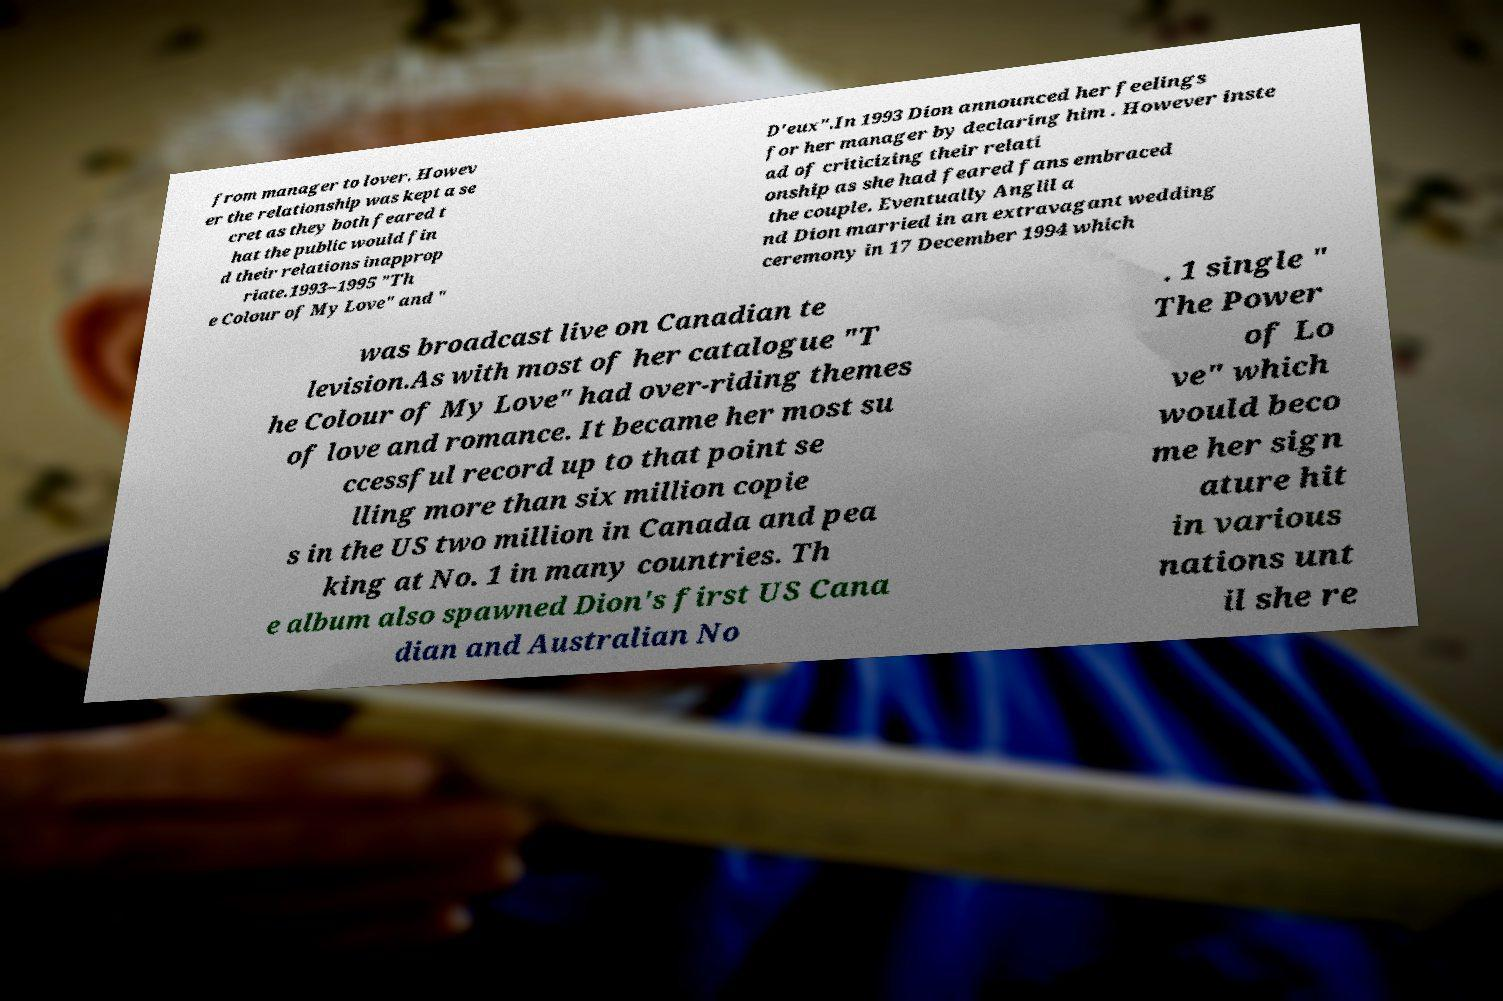For documentation purposes, I need the text within this image transcribed. Could you provide that? from manager to lover. Howev er the relationship was kept a se cret as they both feared t hat the public would fin d their relations inapprop riate.1993–1995 "Th e Colour of My Love" and " D'eux".In 1993 Dion announced her feelings for her manager by declaring him . However inste ad of criticizing their relati onship as she had feared fans embraced the couple. Eventually Anglil a nd Dion married in an extravagant wedding ceremony in 17 December 1994 which was broadcast live on Canadian te levision.As with most of her catalogue "T he Colour of My Love" had over-riding themes of love and romance. It became her most su ccessful record up to that point se lling more than six million copie s in the US two million in Canada and pea king at No. 1 in many countries. Th e album also spawned Dion's first US Cana dian and Australian No . 1 single " The Power of Lo ve" which would beco me her sign ature hit in various nations unt il she re 